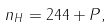Convert formula to latex. <formula><loc_0><loc_0><loc_500><loc_500>n _ { H } = 2 4 4 + P ,</formula> 